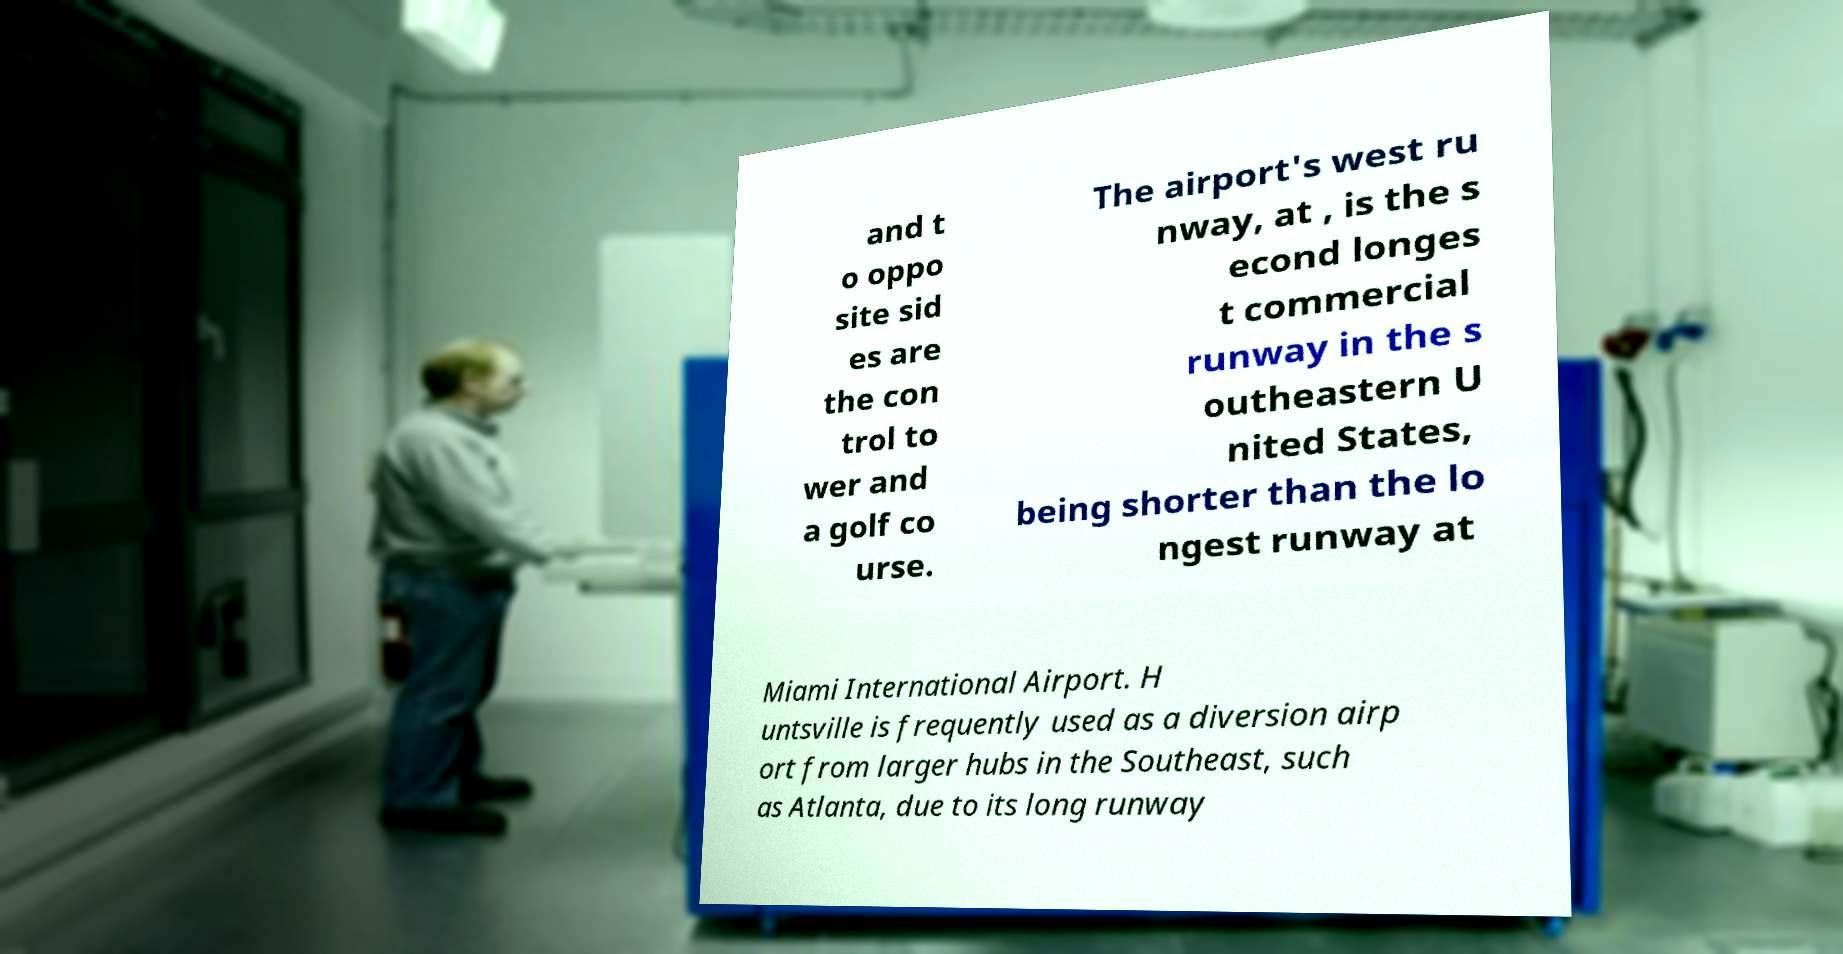For documentation purposes, I need the text within this image transcribed. Could you provide that? and t o oppo site sid es are the con trol to wer and a golf co urse. The airport's west ru nway, at , is the s econd longes t commercial runway in the s outheastern U nited States, being shorter than the lo ngest runway at Miami International Airport. H untsville is frequently used as a diversion airp ort from larger hubs in the Southeast, such as Atlanta, due to its long runway 